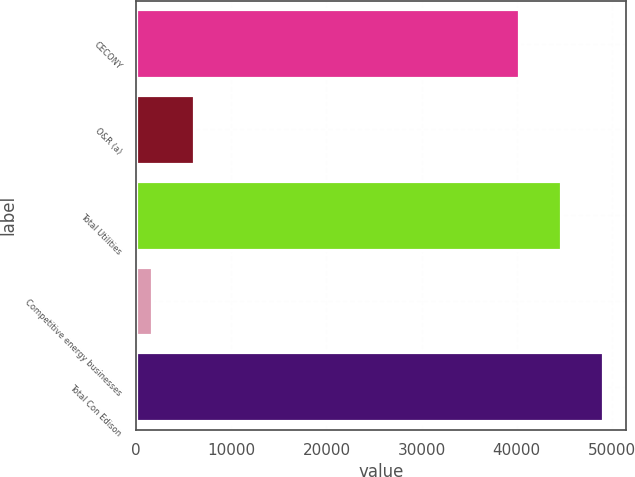<chart> <loc_0><loc_0><loc_500><loc_500><bar_chart><fcel>CECONY<fcel>O&R (a)<fcel>Total Utilities<fcel>Competitive energy businesses<fcel>Total Con Edison<nl><fcel>40230<fcel>6076.2<fcel>44626.2<fcel>1680<fcel>49022.4<nl></chart> 